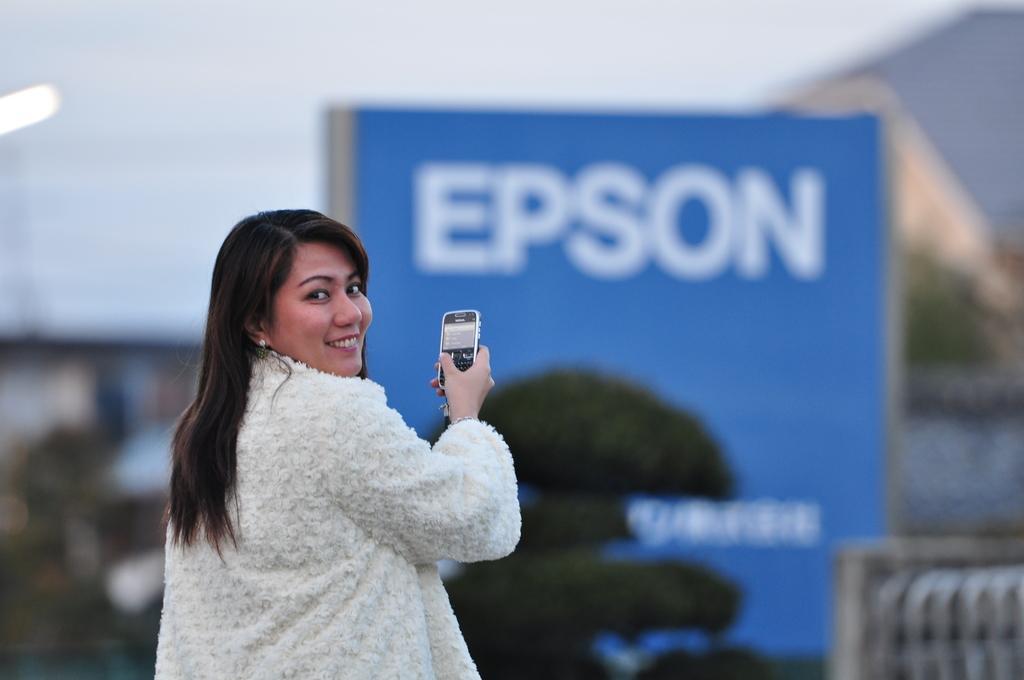Can you describe this image briefly? In this image, we can see a woman standing and she is holding a mobile phone, in the background we can see a blue poster and some trees. 